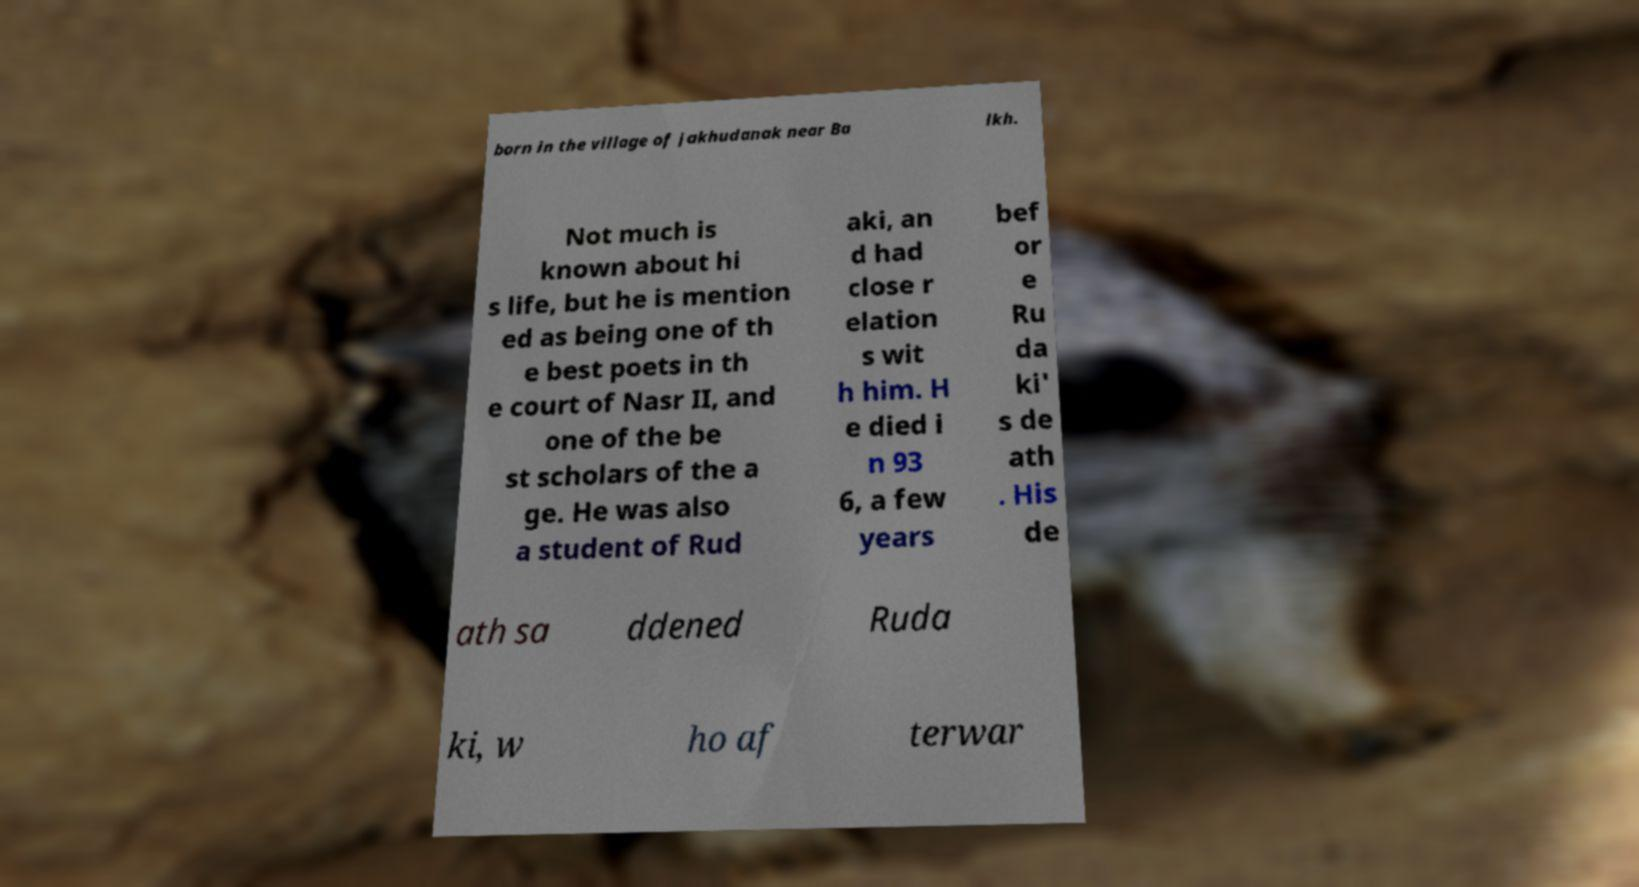For documentation purposes, I need the text within this image transcribed. Could you provide that? born in the village of Jakhudanak near Ba lkh. Not much is known about hi s life, but he is mention ed as being one of th e best poets in th e court of Nasr II, and one of the be st scholars of the a ge. He was also a student of Rud aki, an d had close r elation s wit h him. H e died i n 93 6, a few years bef or e Ru da ki' s de ath . His de ath sa ddened Ruda ki, w ho af terwar 